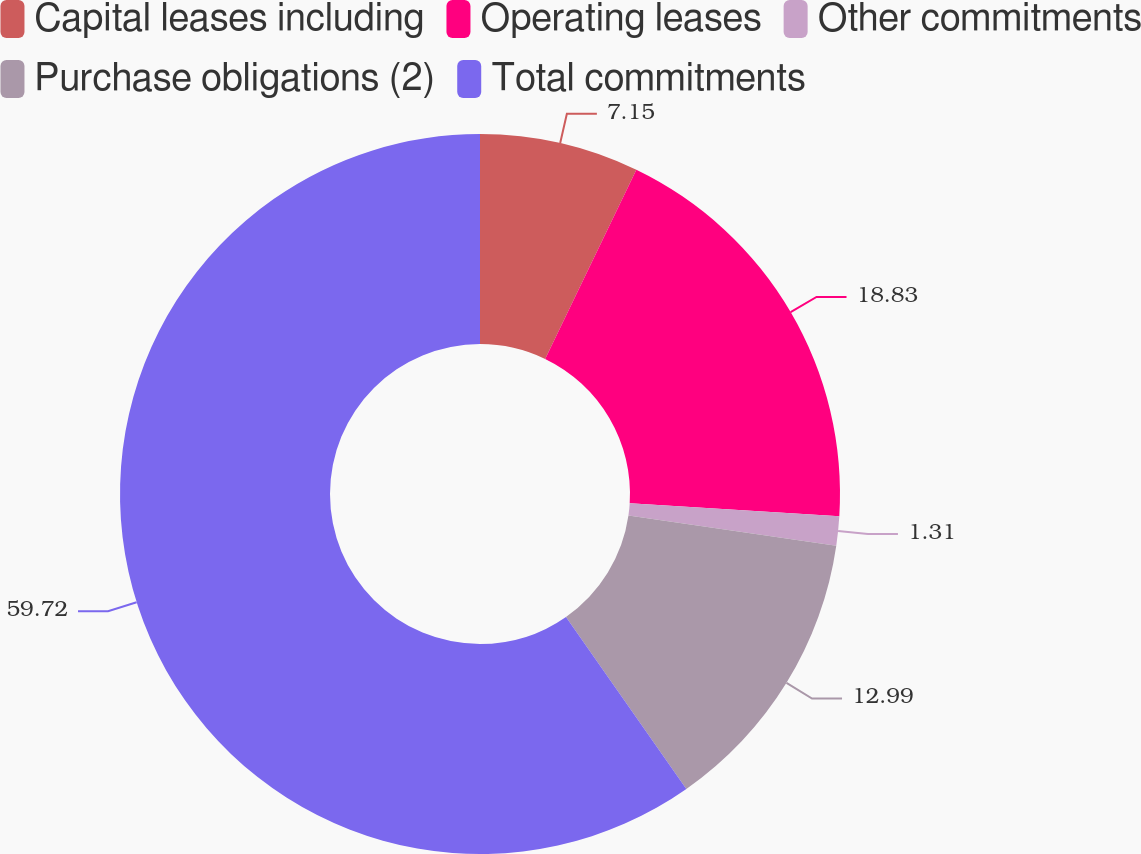Convert chart. <chart><loc_0><loc_0><loc_500><loc_500><pie_chart><fcel>Capital leases including<fcel>Operating leases<fcel>Other commitments<fcel>Purchase obligations (2)<fcel>Total commitments<nl><fcel>7.15%<fcel>18.83%<fcel>1.31%<fcel>12.99%<fcel>59.71%<nl></chart> 